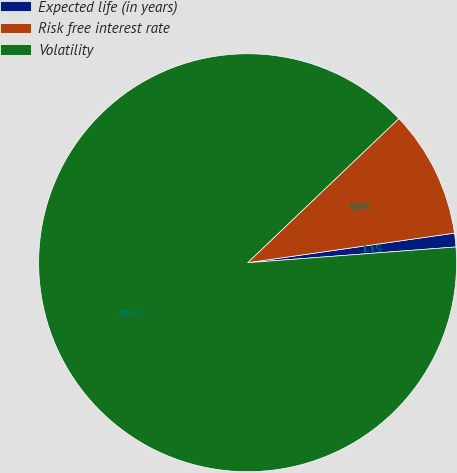Convert chart. <chart><loc_0><loc_0><loc_500><loc_500><pie_chart><fcel>Expected life (in years)<fcel>Risk free interest rate<fcel>Volatility<nl><fcel>1.06%<fcel>9.86%<fcel>89.08%<nl></chart> 